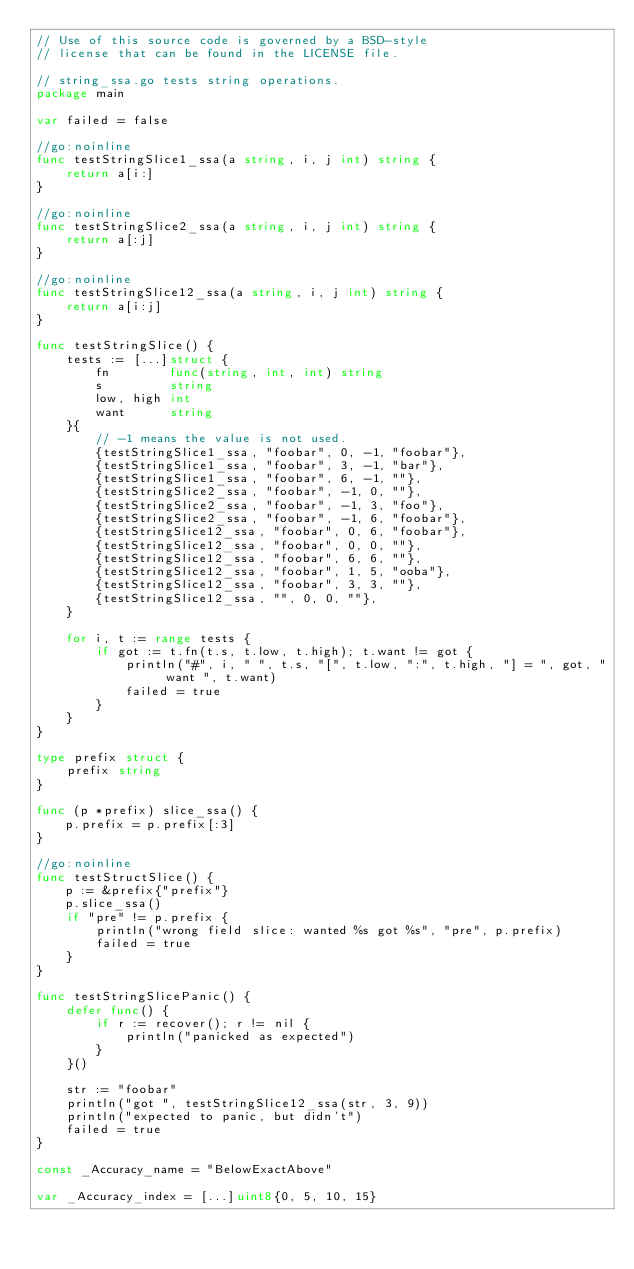<code> <loc_0><loc_0><loc_500><loc_500><_Go_>// Use of this source code is governed by a BSD-style
// license that can be found in the LICENSE file.

// string_ssa.go tests string operations.
package main

var failed = false

//go:noinline
func testStringSlice1_ssa(a string, i, j int) string {
	return a[i:]
}

//go:noinline
func testStringSlice2_ssa(a string, i, j int) string {
	return a[:j]
}

//go:noinline
func testStringSlice12_ssa(a string, i, j int) string {
	return a[i:j]
}

func testStringSlice() {
	tests := [...]struct {
		fn        func(string, int, int) string
		s         string
		low, high int
		want      string
	}{
		// -1 means the value is not used.
		{testStringSlice1_ssa, "foobar", 0, -1, "foobar"},
		{testStringSlice1_ssa, "foobar", 3, -1, "bar"},
		{testStringSlice1_ssa, "foobar", 6, -1, ""},
		{testStringSlice2_ssa, "foobar", -1, 0, ""},
		{testStringSlice2_ssa, "foobar", -1, 3, "foo"},
		{testStringSlice2_ssa, "foobar", -1, 6, "foobar"},
		{testStringSlice12_ssa, "foobar", 0, 6, "foobar"},
		{testStringSlice12_ssa, "foobar", 0, 0, ""},
		{testStringSlice12_ssa, "foobar", 6, 6, ""},
		{testStringSlice12_ssa, "foobar", 1, 5, "ooba"},
		{testStringSlice12_ssa, "foobar", 3, 3, ""},
		{testStringSlice12_ssa, "", 0, 0, ""},
	}

	for i, t := range tests {
		if got := t.fn(t.s, t.low, t.high); t.want != got {
			println("#", i, " ", t.s, "[", t.low, ":", t.high, "] = ", got, " want ", t.want)
			failed = true
		}
	}
}

type prefix struct {
	prefix string
}

func (p *prefix) slice_ssa() {
	p.prefix = p.prefix[:3]
}

//go:noinline
func testStructSlice() {
	p := &prefix{"prefix"}
	p.slice_ssa()
	if "pre" != p.prefix {
		println("wrong field slice: wanted %s got %s", "pre", p.prefix)
		failed = true
	}
}

func testStringSlicePanic() {
	defer func() {
		if r := recover(); r != nil {
			println("panicked as expected")
		}
	}()

	str := "foobar"
	println("got ", testStringSlice12_ssa(str, 3, 9))
	println("expected to panic, but didn't")
	failed = true
}

const _Accuracy_name = "BelowExactAbove"

var _Accuracy_index = [...]uint8{0, 5, 10, 15}
</code> 